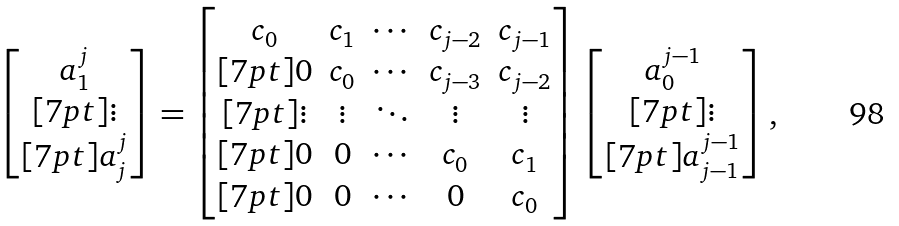Convert formula to latex. <formula><loc_0><loc_0><loc_500><loc_500>\begin{bmatrix} a ^ { j } _ { 1 } \\ [ 7 p t ] \vdots \\ [ 7 p t ] a ^ { j } _ { j } \end{bmatrix} = \begin{bmatrix} c _ { 0 } & c _ { 1 } & \cdots & c _ { j - 2 } & c _ { j - 1 } \\ [ 7 p t ] 0 & c _ { 0 } & \cdots & c _ { j - 3 } & c _ { j - 2 } \\ [ 7 p t ] \vdots & \vdots & \ddots & \vdots & \vdots \\ [ 7 p t ] 0 & 0 & \cdots & c _ { 0 } & c _ { 1 } \\ [ 7 p t ] 0 & 0 & \cdots & 0 & c _ { 0 } \\ \end{bmatrix} \begin{bmatrix} a ^ { j - 1 } _ { 0 } \\ [ 7 p t ] \vdots \\ [ 7 p t ] a ^ { j - 1 } _ { j - 1 } \end{bmatrix} ,</formula> 